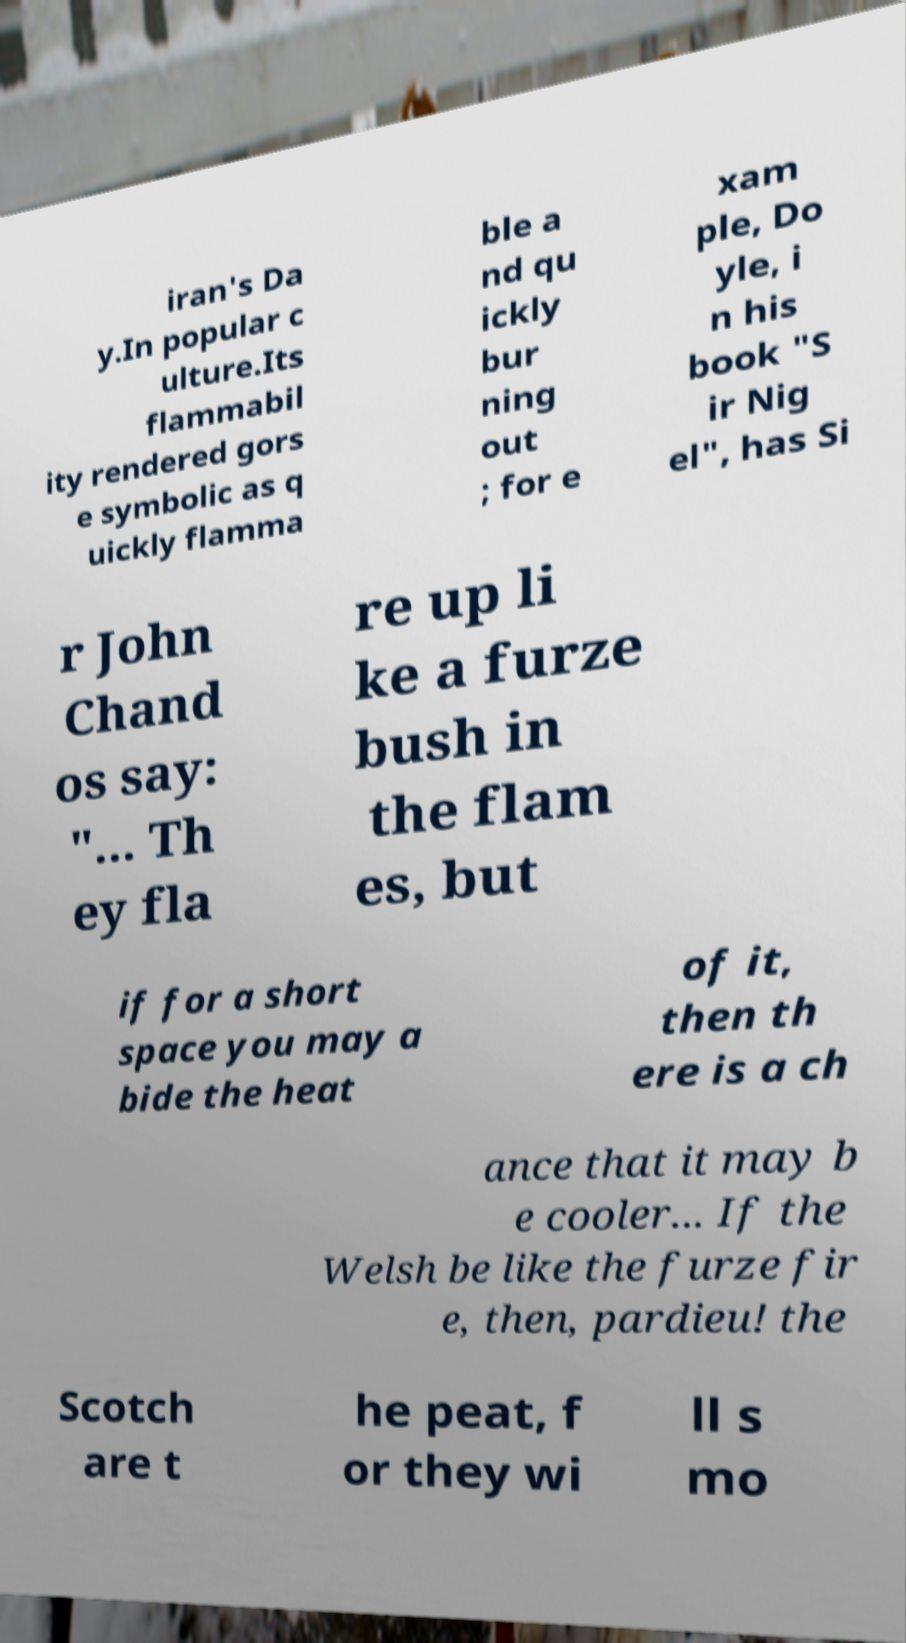Could you extract and type out the text from this image? iran's Da y.In popular c ulture.Its flammabil ity rendered gors e symbolic as q uickly flamma ble a nd qu ickly bur ning out ; for e xam ple, Do yle, i n his book "S ir Nig el", has Si r John Chand os say: "... Th ey fla re up li ke a furze bush in the flam es, but if for a short space you may a bide the heat of it, then th ere is a ch ance that it may b e cooler... If the Welsh be like the furze fir e, then, pardieu! the Scotch are t he peat, f or they wi ll s mo 